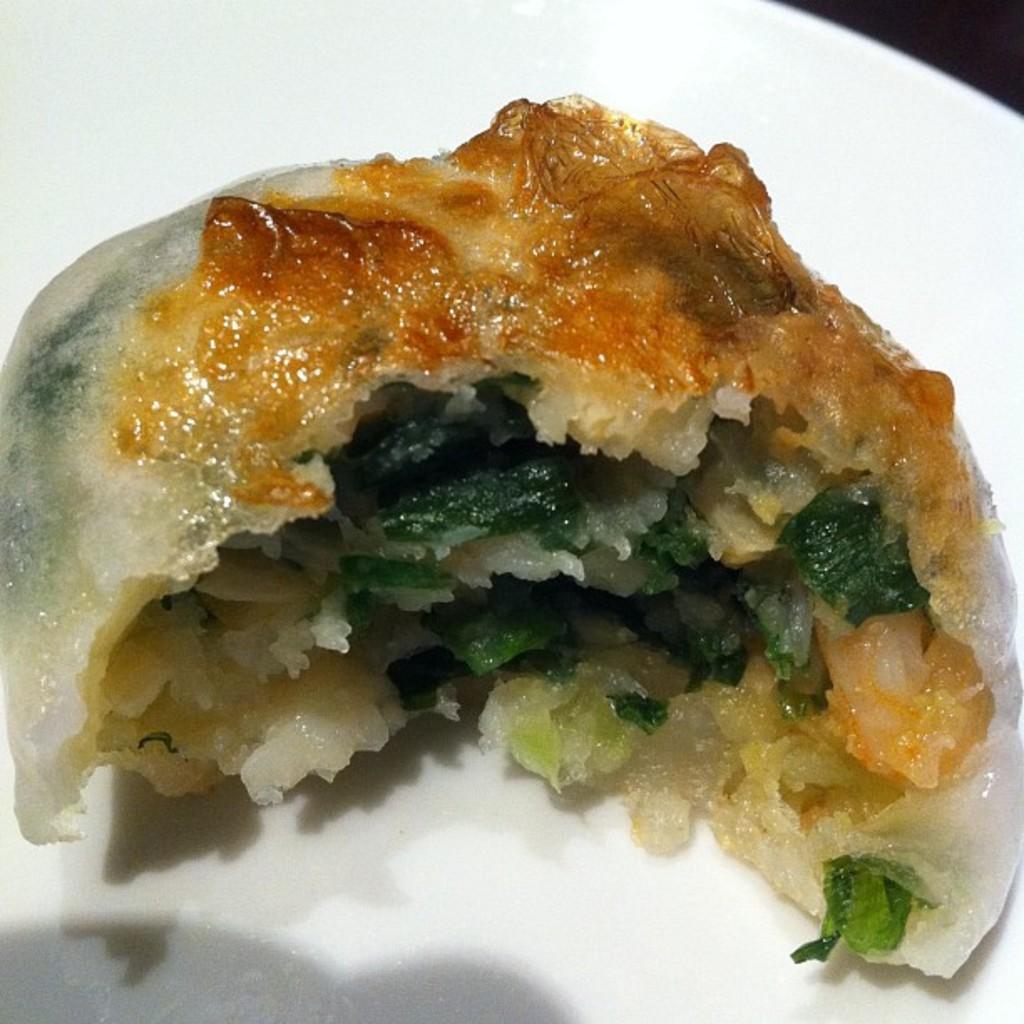Describe this image in one or two sentences. In this picture I can see there is some food places here on the plate and it has some mint leaves in it. 